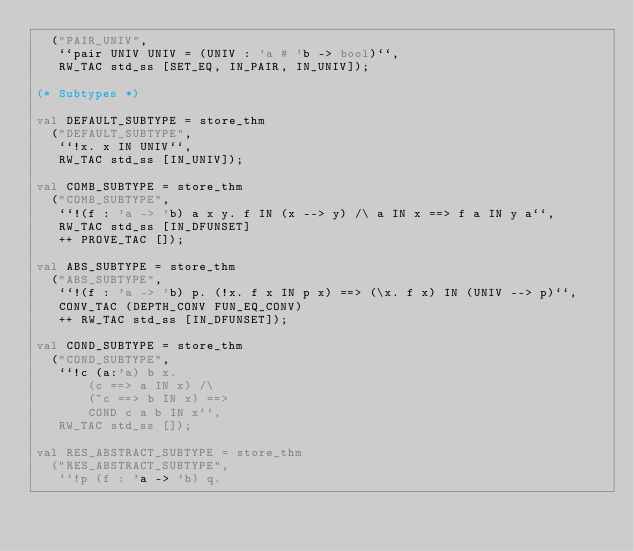Convert code to text. <code><loc_0><loc_0><loc_500><loc_500><_SML_>  ("PAIR_UNIV",
   ``pair UNIV UNIV = (UNIV : 'a # 'b -> bool)``,
   RW_TAC std_ss [SET_EQ, IN_PAIR, IN_UNIV]);

(* Subtypes *)

val DEFAULT_SUBTYPE = store_thm
  ("DEFAULT_SUBTYPE",
   ``!x. x IN UNIV``,
   RW_TAC std_ss [IN_UNIV]);

val COMB_SUBTYPE = store_thm
  ("COMB_SUBTYPE",
   ``!(f : 'a -> 'b) a x y. f IN (x --> y) /\ a IN x ==> f a IN y a``,
   RW_TAC std_ss [IN_DFUNSET]
   ++ PROVE_TAC []);

val ABS_SUBTYPE = store_thm
  ("ABS_SUBTYPE",
   ``!(f : 'a -> 'b) p. (!x. f x IN p x) ==> (\x. f x) IN (UNIV --> p)``,
   CONV_TAC (DEPTH_CONV FUN_EQ_CONV)
   ++ RW_TAC std_ss [IN_DFUNSET]);

val COND_SUBTYPE = store_thm
  ("COND_SUBTYPE",
   ``!c (a:'a) b x.
       (c ==> a IN x) /\
       (~c ==> b IN x) ==>
       COND c a b IN x``,
   RW_TAC std_ss []);

val RES_ABSTRACT_SUBTYPE = store_thm
  ("RES_ABSTRACT_SUBTYPE",
   ``!p (f : 'a -> 'b) q.</code> 